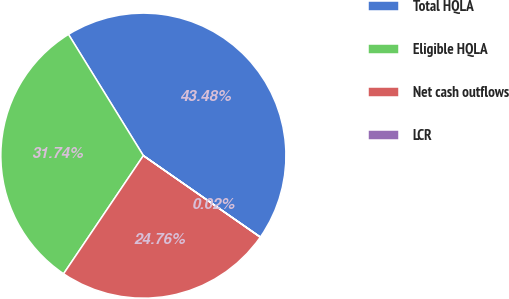Convert chart to OTSL. <chart><loc_0><loc_0><loc_500><loc_500><pie_chart><fcel>Total HQLA<fcel>Eligible HQLA<fcel>Net cash outflows<fcel>LCR<nl><fcel>43.48%<fcel>31.74%<fcel>24.76%<fcel>0.02%<nl></chart> 